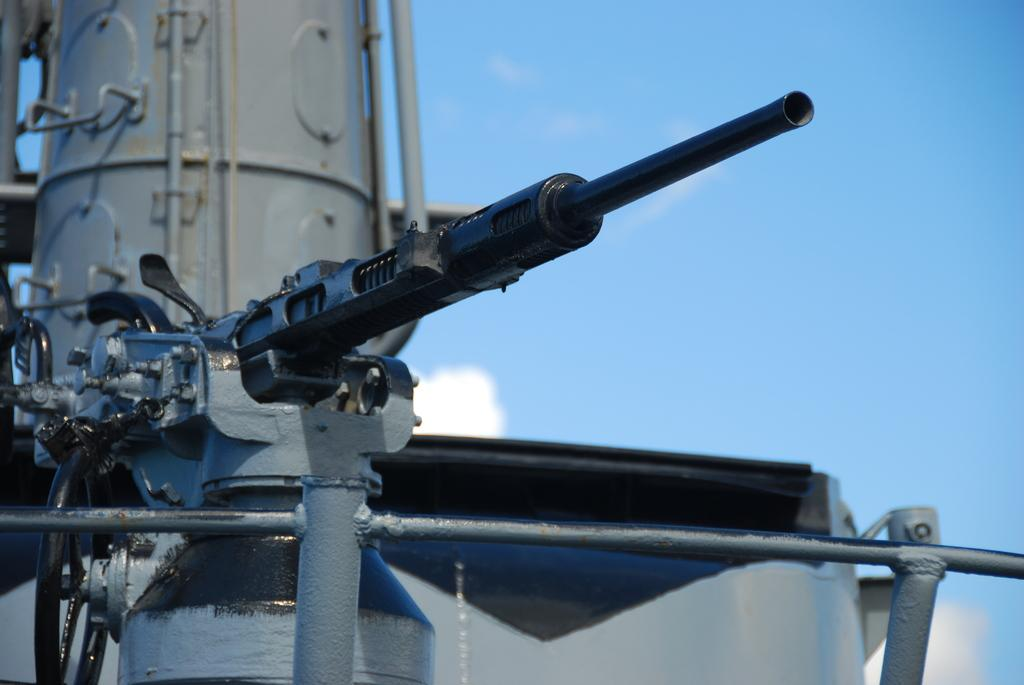What is located in the foreground of the image? There is a metal object in the foreground of the image. What can be seen in the background of the image? The sky is visible in the background of the image. What type of pie is being served by the boy in the image? There is no boy or pie present in the image; it only features a metal object and the sky. 